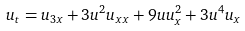Convert formula to latex. <formula><loc_0><loc_0><loc_500><loc_500>u _ { t } = u _ { 3 x } + 3 u ^ { 2 } u _ { x x } + 9 u u _ { x } ^ { 2 } + 3 u ^ { 4 } u _ { x }</formula> 